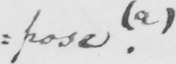What text is written in this handwritten line? : pose . ( a ) 